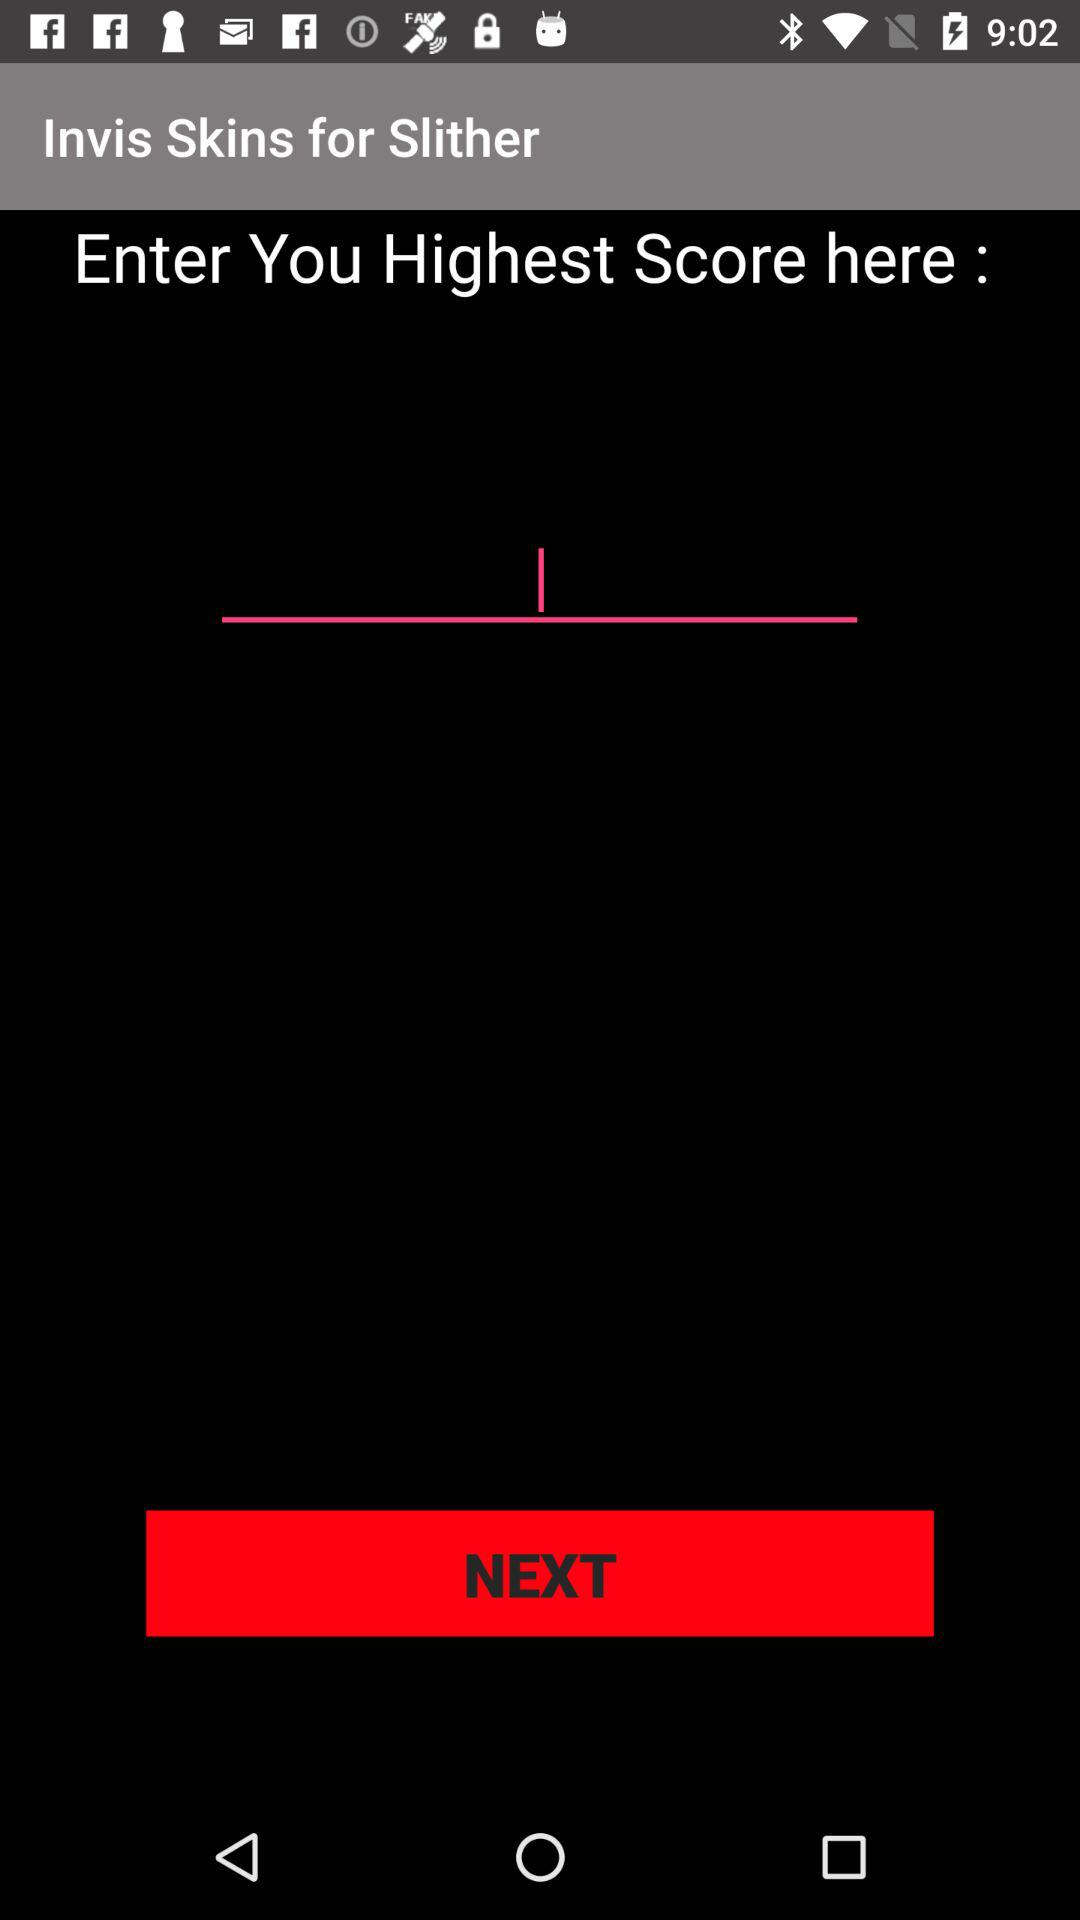What is the application name? The application name is "Invis Skins for Slither". 